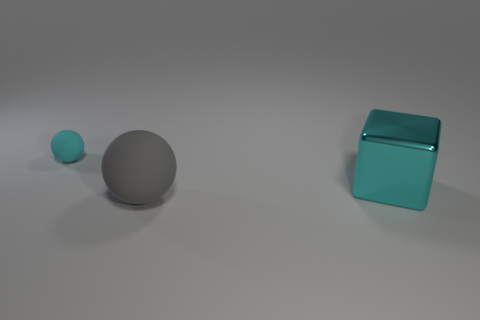Add 2 big metallic blocks. How many objects exist? 5 Subtract all spheres. How many objects are left? 1 Subtract 0 purple cylinders. How many objects are left? 3 Subtract all big balls. Subtract all large matte spheres. How many objects are left? 1 Add 3 large gray balls. How many large gray balls are left? 4 Add 2 tiny brown metal spheres. How many tiny brown metal spheres exist? 2 